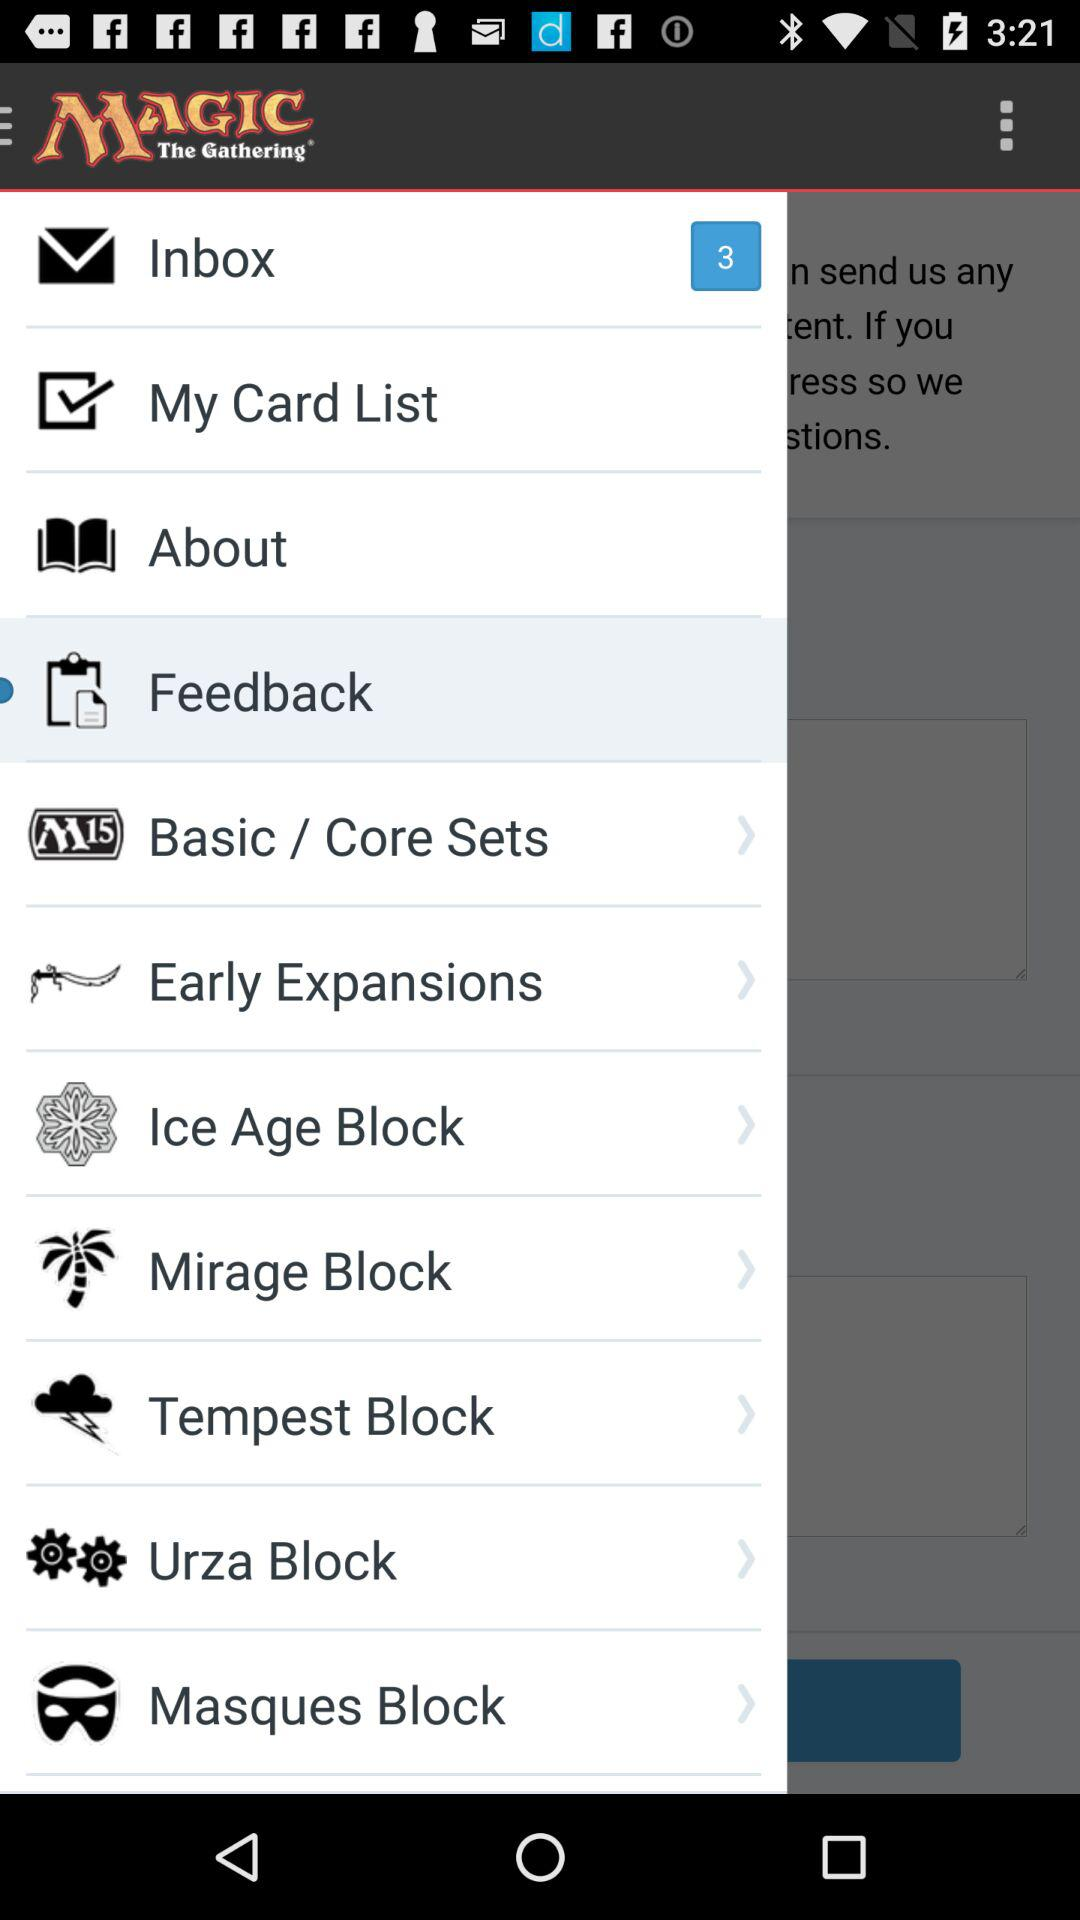How many unread messages are in the inbox? There are 3 unread messages. 